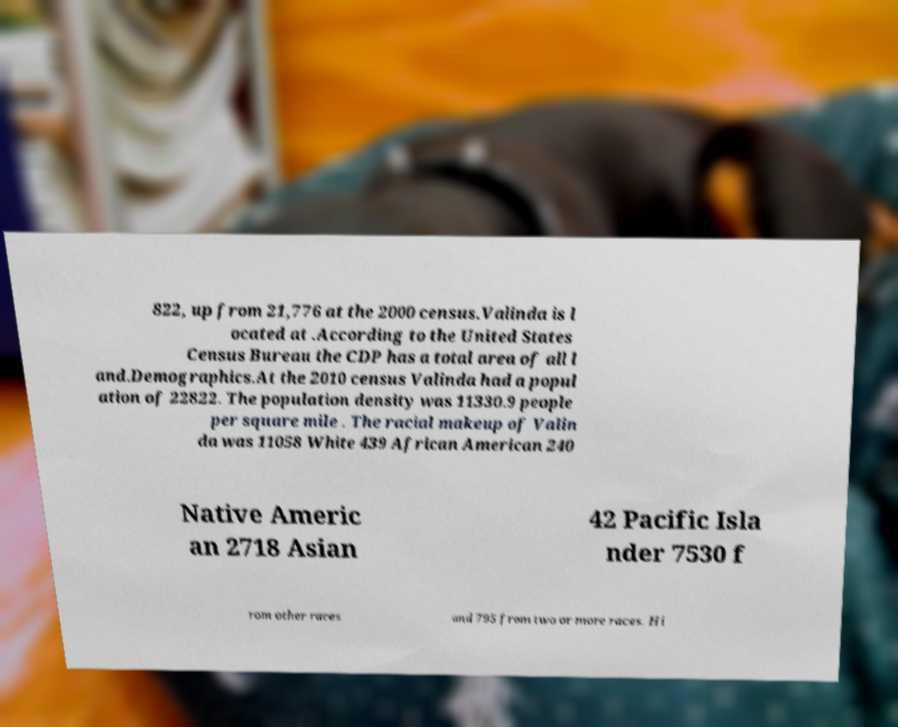I need the written content from this picture converted into text. Can you do that? 822, up from 21,776 at the 2000 census.Valinda is l ocated at .According to the United States Census Bureau the CDP has a total area of all l and.Demographics.At the 2010 census Valinda had a popul ation of 22822. The population density was 11330.9 people per square mile . The racial makeup of Valin da was 11058 White 439 African American 240 Native Americ an 2718 Asian 42 Pacific Isla nder 7530 f rom other races and 795 from two or more races. Hi 